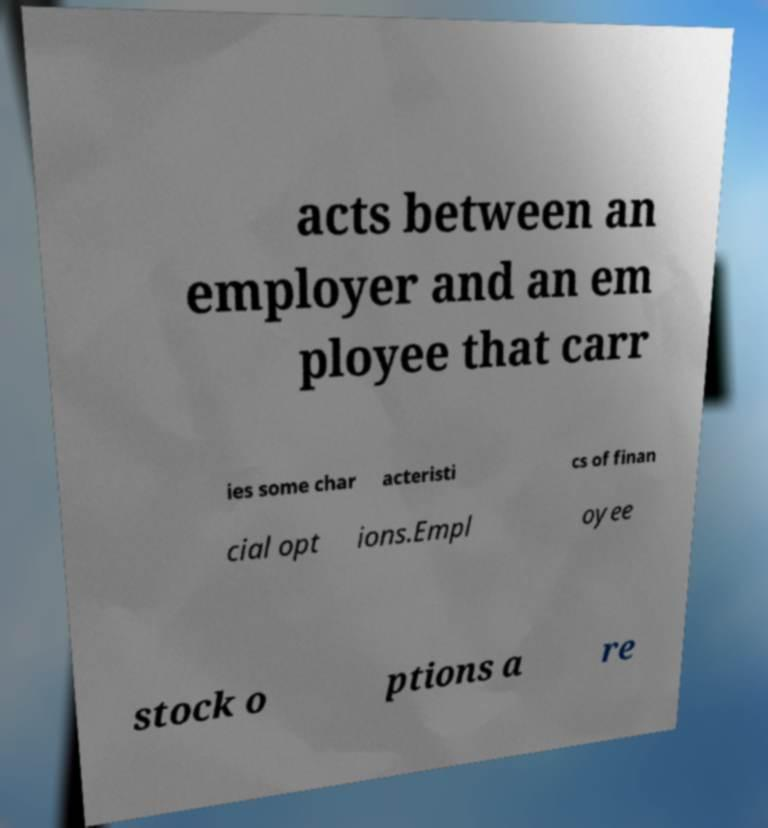For documentation purposes, I need the text within this image transcribed. Could you provide that? acts between an employer and an em ployee that carr ies some char acteristi cs of finan cial opt ions.Empl oyee stock o ptions a re 